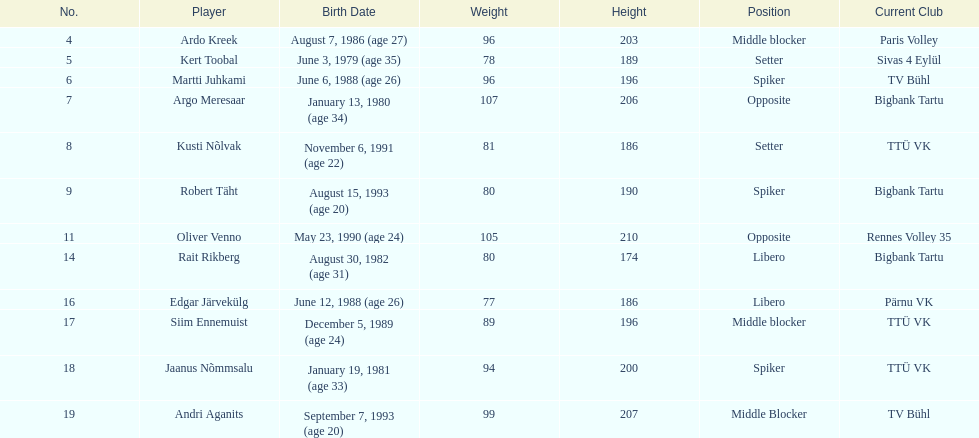Who is 25 years of age or more? Ardo Kreek, Kert Toobal, Martti Juhkami, Argo Meresaar, Rait Rikberg, Edgar Järvekülg, Jaanus Nõmmsalu. 